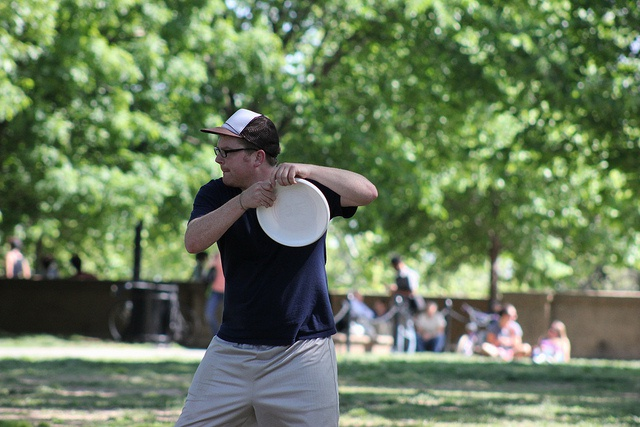Describe the objects in this image and their specific colors. I can see people in olive, black, and gray tones, frisbee in olive, darkgray, gray, and white tones, people in olive, gray, lavender, black, and darkgray tones, people in olive, lavender, gray, lightpink, and darkgray tones, and people in olive, lavender, darkgray, gray, and pink tones in this image. 